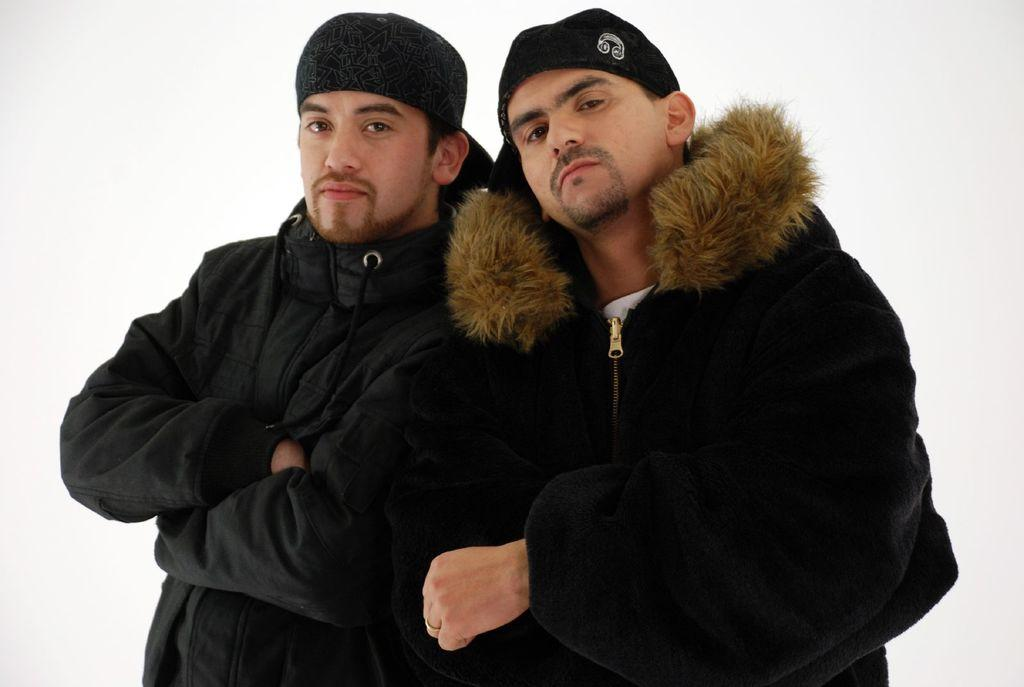How many people are in the image? There are two persons standing in the center of the image. What are the people wearing on their heads? Both persons are wearing caps. What type of clothing are the people wearing on their upper bodies? Both persons are wearing jackets. What is the color of the background in the image? The background of the image is white. How many cats can be seen playing in the house in the image? There are no cats or houses present in the image; it features two persons standing in the center. What type of van is parked in front of the persons in the image? There is no van present in the image; it only shows two persons standing in the center with a white background. 